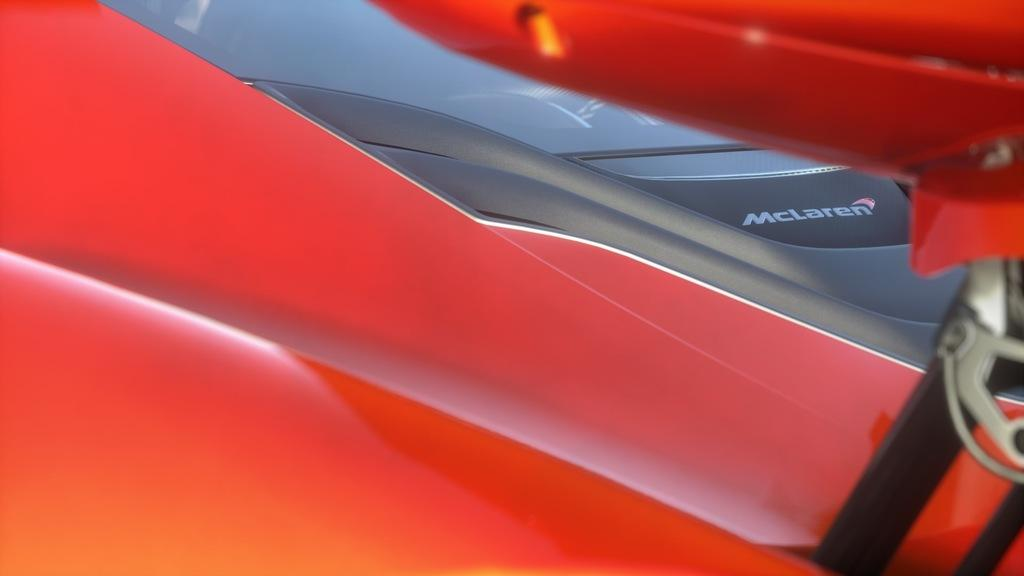What type of car is in the picture? There is a red McLaren car in the picture. Which direction is the car facing in the picture? The provided facts do not mention the direction the car is facing, so it cannot be determined from the image. 